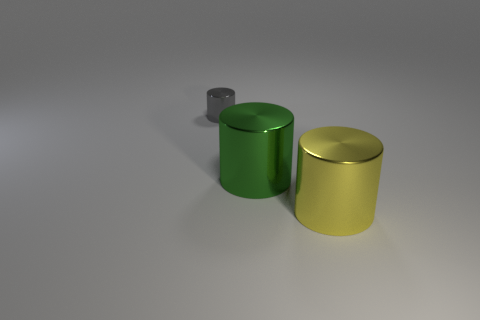Is there anything else that has the same color as the small shiny object?
Ensure brevity in your answer.  No. What is the shape of the big shiny thing behind the large yellow thing?
Provide a succinct answer. Cylinder. Is the color of the tiny cylinder the same as the thing right of the big green metallic thing?
Offer a terse response. No. Are there an equal number of big metallic cylinders that are to the left of the green cylinder and green metal things that are right of the small gray cylinder?
Provide a short and direct response. No. What number of other objects are the same size as the green metallic cylinder?
Your response must be concise. 1. The gray metal thing is what size?
Your response must be concise. Small. Does the gray thing have the same material as the large thing to the left of the large yellow metallic object?
Your answer should be compact. Yes. Are there any gray shiny things of the same shape as the big yellow thing?
Give a very brief answer. Yes. There is a yellow thing that is the same size as the green object; what material is it?
Your answer should be very brief. Metal. There is a cylinder that is to the right of the green shiny thing; how big is it?
Your answer should be compact. Large. 